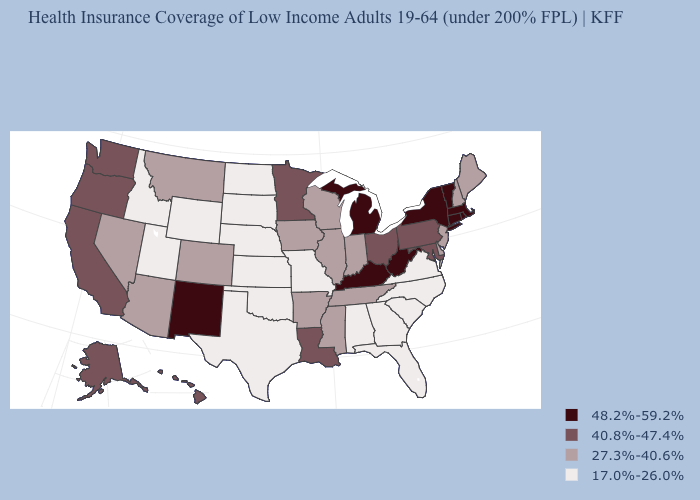Name the states that have a value in the range 27.3%-40.6%?
Short answer required. Arizona, Arkansas, Colorado, Delaware, Illinois, Indiana, Iowa, Maine, Mississippi, Montana, Nevada, New Hampshire, New Jersey, Tennessee, Wisconsin. Which states have the lowest value in the MidWest?
Concise answer only. Kansas, Missouri, Nebraska, North Dakota, South Dakota. What is the value of Hawaii?
Write a very short answer. 40.8%-47.4%. What is the highest value in states that border Tennessee?
Quick response, please. 48.2%-59.2%. What is the value of Rhode Island?
Give a very brief answer. 48.2%-59.2%. Does the first symbol in the legend represent the smallest category?
Answer briefly. No. What is the value of Georgia?
Keep it brief. 17.0%-26.0%. Does the first symbol in the legend represent the smallest category?
Write a very short answer. No. What is the highest value in the South ?
Write a very short answer. 48.2%-59.2%. Which states hav the highest value in the South?
Quick response, please. Kentucky, West Virginia. Name the states that have a value in the range 27.3%-40.6%?
Concise answer only. Arizona, Arkansas, Colorado, Delaware, Illinois, Indiana, Iowa, Maine, Mississippi, Montana, Nevada, New Hampshire, New Jersey, Tennessee, Wisconsin. Name the states that have a value in the range 27.3%-40.6%?
Quick response, please. Arizona, Arkansas, Colorado, Delaware, Illinois, Indiana, Iowa, Maine, Mississippi, Montana, Nevada, New Hampshire, New Jersey, Tennessee, Wisconsin. What is the lowest value in the South?
Give a very brief answer. 17.0%-26.0%. What is the value of Florida?
Concise answer only. 17.0%-26.0%. What is the highest value in states that border Tennessee?
Keep it brief. 48.2%-59.2%. 